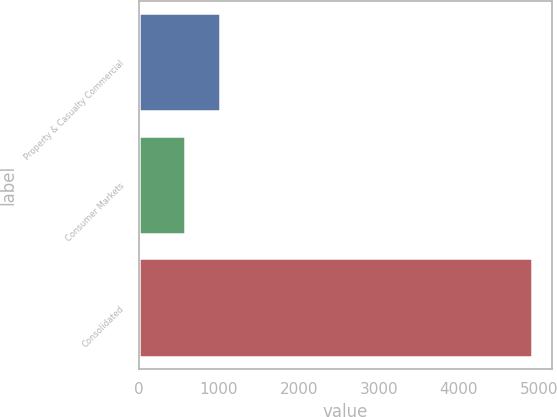<chart> <loc_0><loc_0><loc_500><loc_500><bar_chart><fcel>Property & Casualty Commercial<fcel>Consumer Markets<fcel>Consolidated<nl><fcel>1011.7<fcel>578<fcel>4915<nl></chart> 